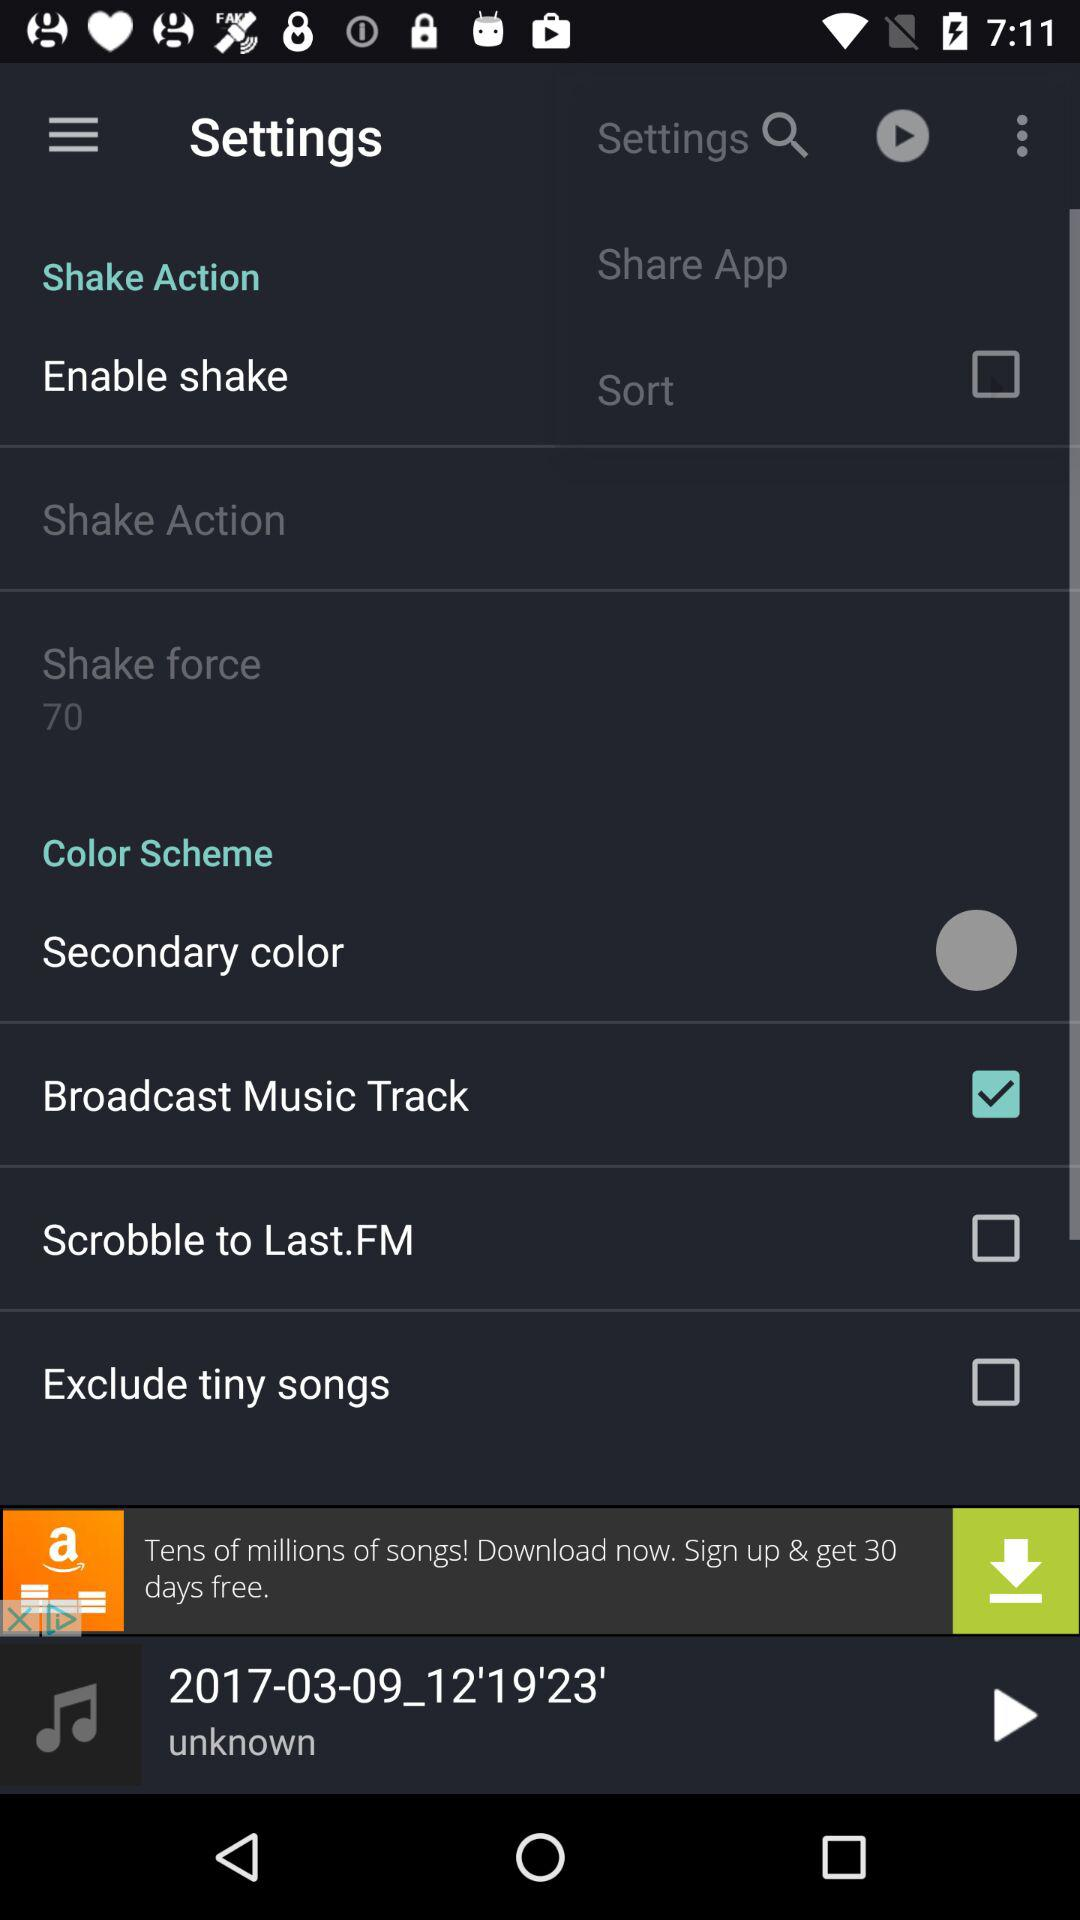What is the current status of the excluded tiny songs? The status is off. 